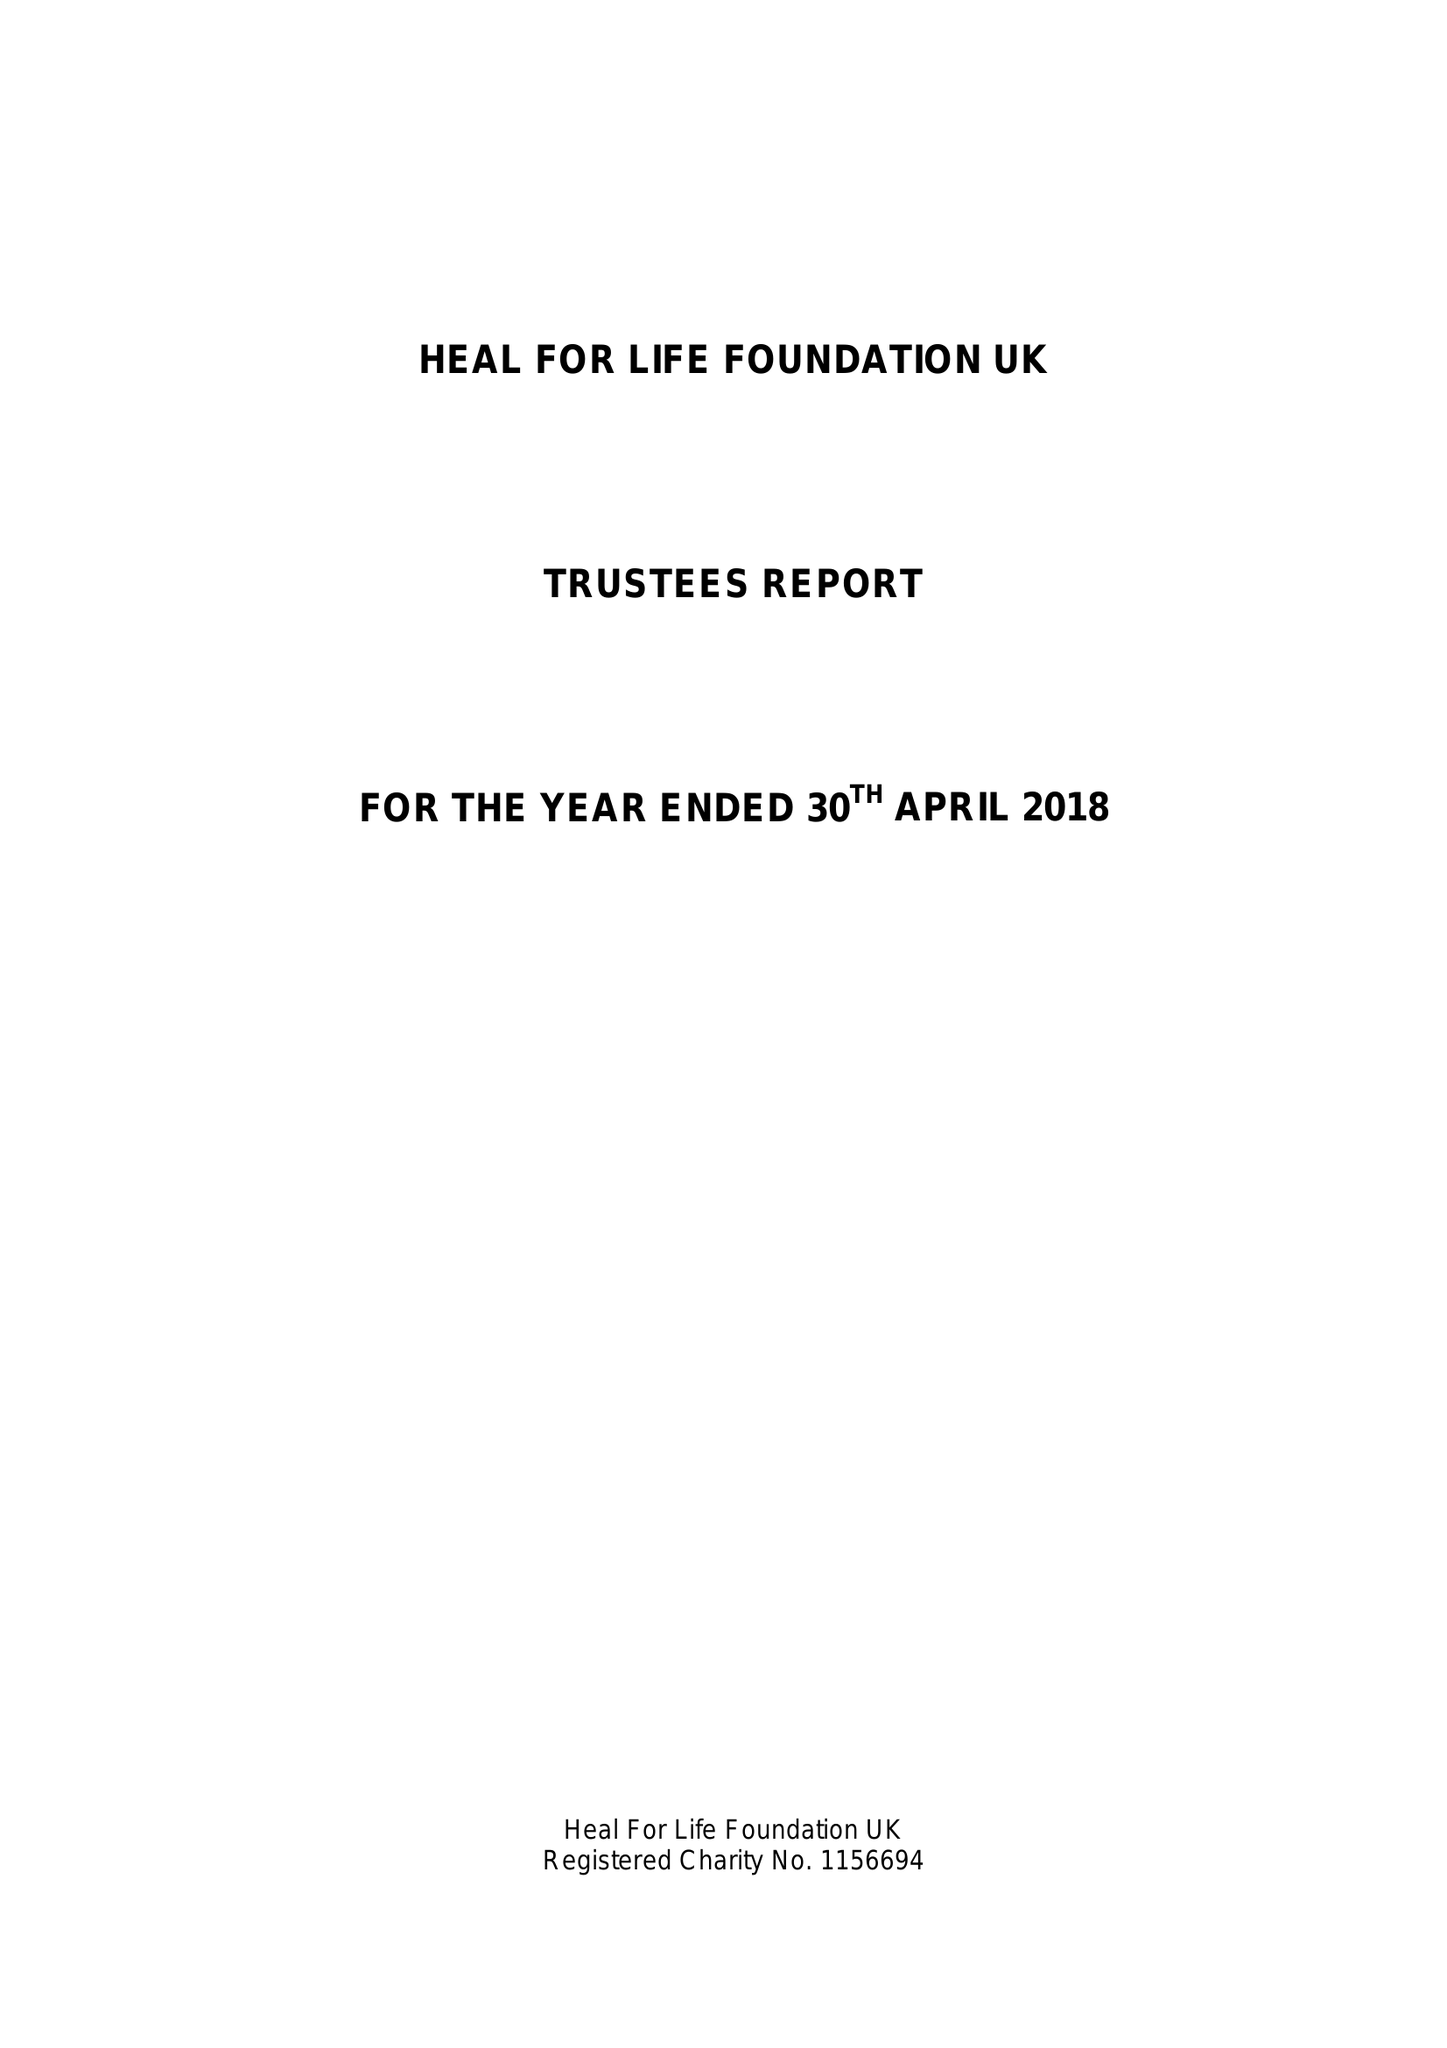What is the value for the income_annually_in_british_pounds?
Answer the question using a single word or phrase. 10565.58 